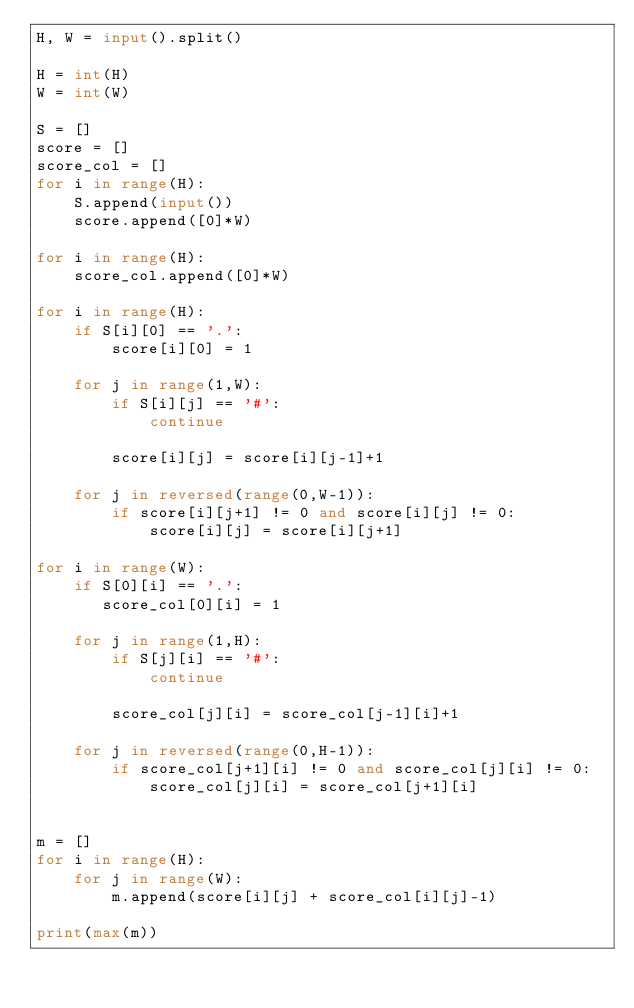Convert code to text. <code><loc_0><loc_0><loc_500><loc_500><_Python_>H, W = input().split()

H = int(H)
W = int(W)

S = []
score = []
score_col = []
for i in range(H):
    S.append(input())
    score.append([0]*W)

for i in range(H):
    score_col.append([0]*W)
    
for i in range(H):
    if S[i][0] == '.':
        score[i][0] = 1

    for j in range(1,W):
        if S[i][j] == '#':
            continue

        score[i][j] = score[i][j-1]+1

    for j in reversed(range(0,W-1)):
        if score[i][j+1] != 0 and score[i][j] != 0:
            score[i][j] = score[i][j+1]
    
for i in range(W):
    if S[0][i] == '.':
       score_col[0][i] = 1

    for j in range(1,H):
        if S[j][i] == '#':
            continue

        score_col[j][i] = score_col[j-1][i]+1

    for j in reversed(range(0,H-1)):
        if score_col[j+1][i] != 0 and score_col[j][i] != 0:
            score_col[j][i] = score_col[j+1][i]


m = []            
for i in range(H):
    for j in range(W):
        m.append(score[i][j] + score_col[i][j]-1)

print(max(m))
</code> 